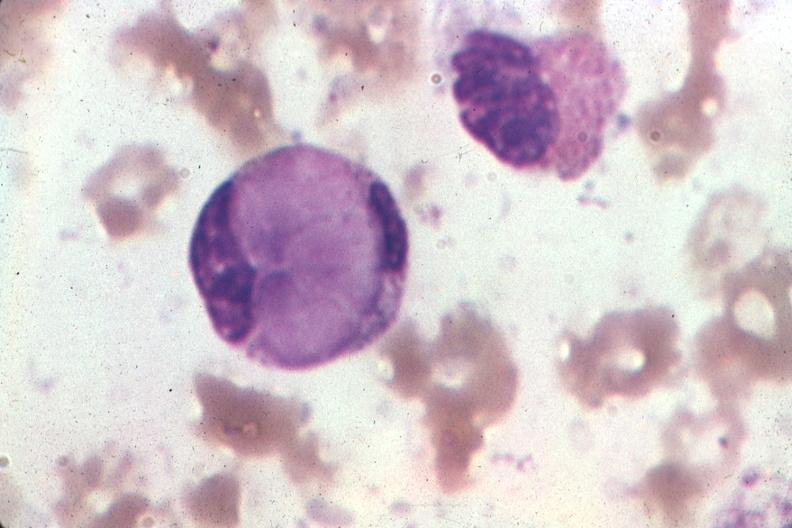s papillary intraductal adenocarcinoma present?
Answer the question using a single word or phrase. No 